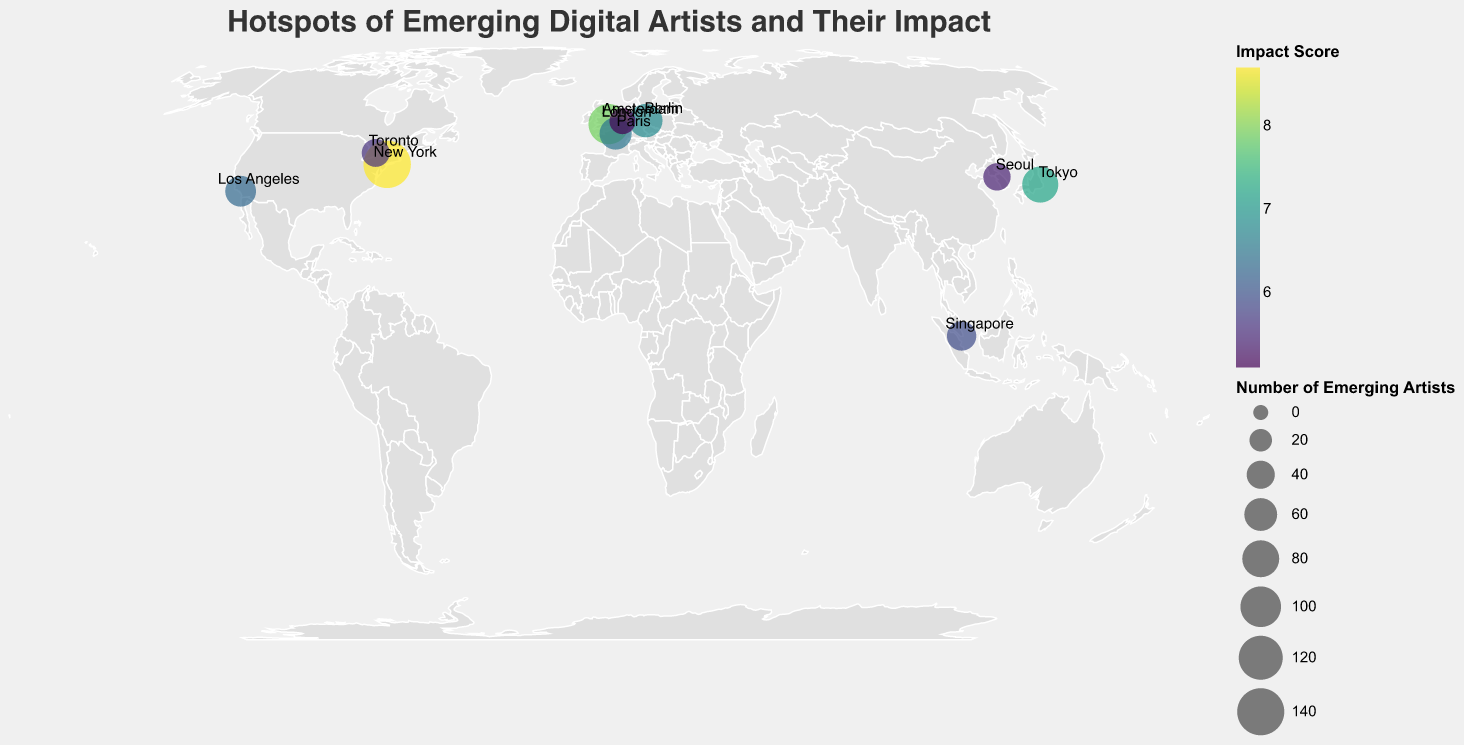What's the highest impact score on the map? Look at the color scale corresponding to the Impact Score. The darkest color on the plot represents the highest impact score, which is located at New York. The label shows an impact score of 8.7
Answer: 8.7 Which city has the most emerging digital artists? The size of the circles represents the number of emerging artists. The largest circle is in New York, which has 142 emerging artists as shown in the data
Answer: New York How many cities have an impact score higher than 7? Look at the cities with circles that fall into the darker side of the color scale. These are New York (8.7), London (7.9), and Tokyo (7.2). Adding them up, there are three cities
Answer: 3 What's the average number of emerging artists in the cities displayed? Sum up the number of emerging artists in each city and divide by the total number of cities. (142 + 98 + 76 + 63 + 57 + 51 + 45 + 39 + 37 + 32) / 10 = 64
Answer: 64 Which city has the lowest impact score and what is it? The lightest color denotes the lowest impact score. This is located at Amsterdam, with a score of 5.1 as labeled
Answer: Amsterdam, 5.1 Among the top five cities with the most emerging artists, which one has the lowest impact score? The top five cities by emerging artists are New York, London, Tokyo, Berlin, and Paris. Their impact scores are 8.7, 7.9, 7.2, 6.8, and 6.5 respectively. Paris has the lowest impact score among them
Answer: Paris Identify the city with the smallest number of emerging artists and its impact score The smallest circle indicates the smallest number of emerging artists, which is Amsterdam with 32 artists and an impact score of 5.1
Answer: Amsterdam, 5.1 Which notable NFT platform is associated with the highest number of emerging artists' city? Look at the city with the highest number of emerging artists, which is New York with OpenSea as the notable NFT platform
Answer: OpenSea Compare the total number of emerging artists in North America to those in Europe North American cities: New York (142) + Los Angeles (51) + Toronto (39) = 232. European cities: London (98) + Berlin (63) + Paris (57) + Amsterdam (32) = 250. Europe has 250 - 232 = 18 more emerging artists than North America
Answer: Europe, 18 